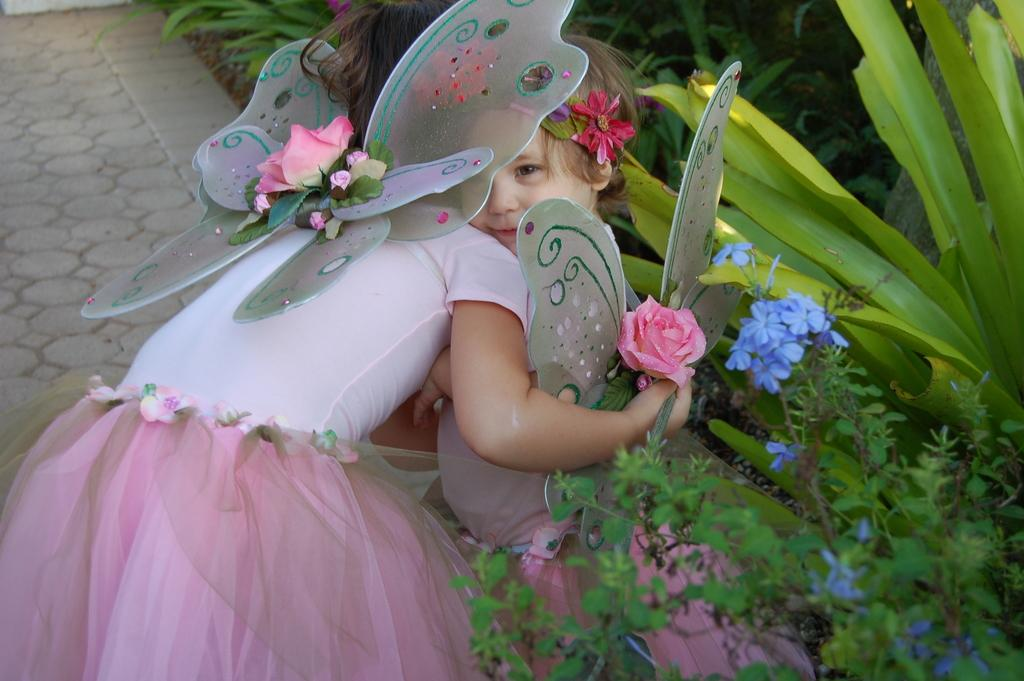Who are the main subjects in the image? There are two girls in the center of the image. What can be seen on the right side of the image? There are flowers and plants on the right side of the image. What is visible in the background of the image? There are plants and a floor visible in the background of the image. How does the party pull the crush in the image? There is no party or crush present in the image; it features two girls and plants. 